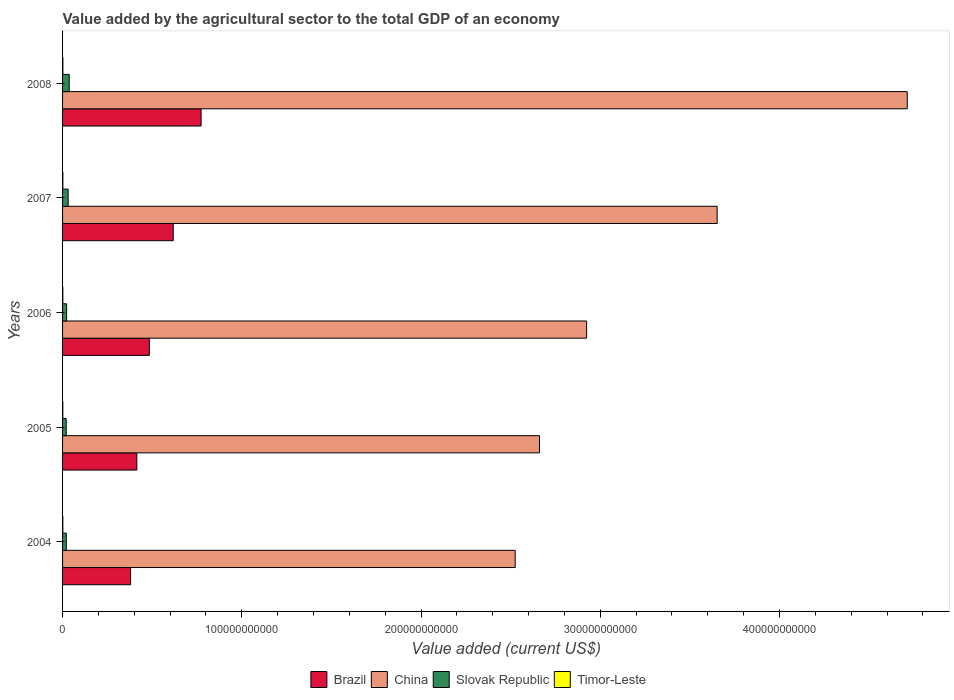Are the number of bars on each tick of the Y-axis equal?
Offer a terse response. Yes. What is the label of the 5th group of bars from the top?
Keep it short and to the point. 2004. In how many cases, is the number of bars for a given year not equal to the number of legend labels?
Ensure brevity in your answer.  0. What is the value added by the agricultural sector to the total GDP in China in 2006?
Your answer should be very brief. 2.92e+11. Across all years, what is the maximum value added by the agricultural sector to the total GDP in Brazil?
Keep it short and to the point. 7.73e+1. Across all years, what is the minimum value added by the agricultural sector to the total GDP in Brazil?
Your answer should be very brief. 3.80e+1. In which year was the value added by the agricultural sector to the total GDP in China minimum?
Provide a succinct answer. 2004. What is the total value added by the agricultural sector to the total GDP in China in the graph?
Give a very brief answer. 1.65e+12. What is the difference between the value added by the agricultural sector to the total GDP in China in 2004 and that in 2006?
Provide a short and direct response. -3.98e+1. What is the difference between the value added by the agricultural sector to the total GDP in Brazil in 2008 and the value added by the agricultural sector to the total GDP in China in 2007?
Provide a short and direct response. -2.88e+11. What is the average value added by the agricultural sector to the total GDP in Slovak Republic per year?
Provide a succinct answer. 2.64e+09. In the year 2006, what is the difference between the value added by the agricultural sector to the total GDP in Timor-Leste and value added by the agricultural sector to the total GDP in Slovak Republic?
Your answer should be compact. -2.12e+09. In how many years, is the value added by the agricultural sector to the total GDP in Slovak Republic greater than 200000000000 US$?
Offer a terse response. 0. What is the ratio of the value added by the agricultural sector to the total GDP in Slovak Republic in 2007 to that in 2008?
Make the answer very short. 0.84. Is the difference between the value added by the agricultural sector to the total GDP in Timor-Leste in 2004 and 2006 greater than the difference between the value added by the agricultural sector to the total GDP in Slovak Republic in 2004 and 2006?
Provide a short and direct response. Yes. What is the difference between the highest and the second highest value added by the agricultural sector to the total GDP in China?
Keep it short and to the point. 1.06e+11. What is the difference between the highest and the lowest value added by the agricultural sector to the total GDP in Timor-Leste?
Make the answer very short. 3.60e+07. In how many years, is the value added by the agricultural sector to the total GDP in Slovak Republic greater than the average value added by the agricultural sector to the total GDP in Slovak Republic taken over all years?
Your response must be concise. 2. What does the 4th bar from the top in 2007 represents?
Keep it short and to the point. Brazil. What does the 3rd bar from the bottom in 2007 represents?
Offer a terse response. Slovak Republic. Is it the case that in every year, the sum of the value added by the agricultural sector to the total GDP in Slovak Republic and value added by the agricultural sector to the total GDP in China is greater than the value added by the agricultural sector to the total GDP in Timor-Leste?
Offer a terse response. Yes. What is the difference between two consecutive major ticks on the X-axis?
Offer a very short reply. 1.00e+11. Does the graph contain any zero values?
Ensure brevity in your answer.  No. How are the legend labels stacked?
Give a very brief answer. Horizontal. What is the title of the graph?
Offer a terse response. Value added by the agricultural sector to the total GDP of an economy. What is the label or title of the X-axis?
Offer a very short reply. Value added (current US$). What is the label or title of the Y-axis?
Your answer should be very brief. Years. What is the Value added (current US$) in Brazil in 2004?
Your answer should be very brief. 3.80e+1. What is the Value added (current US$) of China in 2004?
Your response must be concise. 2.53e+11. What is the Value added (current US$) of Slovak Republic in 2004?
Your response must be concise. 2.09e+09. What is the Value added (current US$) in Timor-Leste in 2004?
Your response must be concise. 1.35e+08. What is the Value added (current US$) of Brazil in 2005?
Offer a terse response. 4.14e+1. What is the Value added (current US$) of China in 2005?
Ensure brevity in your answer.  2.66e+11. What is the Value added (current US$) of Slovak Republic in 2005?
Your response must be concise. 2.02e+09. What is the Value added (current US$) in Timor-Leste in 2005?
Make the answer very short. 1.35e+08. What is the Value added (current US$) in Brazil in 2006?
Your answer should be very brief. 4.84e+1. What is the Value added (current US$) of China in 2006?
Your response must be concise. 2.92e+11. What is the Value added (current US$) in Slovak Republic in 2006?
Give a very brief answer. 2.27e+09. What is the Value added (current US$) of Timor-Leste in 2006?
Your answer should be compact. 1.45e+08. What is the Value added (current US$) in Brazil in 2007?
Your answer should be compact. 6.17e+1. What is the Value added (current US$) of China in 2007?
Make the answer very short. 3.65e+11. What is the Value added (current US$) of Slovak Republic in 2007?
Your answer should be compact. 3.11e+09. What is the Value added (current US$) of Timor-Leste in 2007?
Provide a succinct answer. 1.59e+08. What is the Value added (current US$) of Brazil in 2008?
Your answer should be very brief. 7.73e+1. What is the Value added (current US$) of China in 2008?
Keep it short and to the point. 4.71e+11. What is the Value added (current US$) in Slovak Republic in 2008?
Offer a very short reply. 3.71e+09. What is the Value added (current US$) in Timor-Leste in 2008?
Provide a short and direct response. 1.71e+08. Across all years, what is the maximum Value added (current US$) in Brazil?
Provide a short and direct response. 7.73e+1. Across all years, what is the maximum Value added (current US$) of China?
Your answer should be very brief. 4.71e+11. Across all years, what is the maximum Value added (current US$) of Slovak Republic?
Make the answer very short. 3.71e+09. Across all years, what is the maximum Value added (current US$) in Timor-Leste?
Keep it short and to the point. 1.71e+08. Across all years, what is the minimum Value added (current US$) of Brazil?
Make the answer very short. 3.80e+1. Across all years, what is the minimum Value added (current US$) of China?
Offer a terse response. 2.53e+11. Across all years, what is the minimum Value added (current US$) of Slovak Republic?
Your response must be concise. 2.02e+09. Across all years, what is the minimum Value added (current US$) of Timor-Leste?
Offer a terse response. 1.35e+08. What is the total Value added (current US$) of Brazil in the graph?
Give a very brief answer. 2.67e+11. What is the total Value added (current US$) of China in the graph?
Offer a very short reply. 1.65e+12. What is the total Value added (current US$) in Slovak Republic in the graph?
Give a very brief answer. 1.32e+1. What is the total Value added (current US$) in Timor-Leste in the graph?
Your answer should be very brief. 7.45e+08. What is the difference between the Value added (current US$) of Brazil in 2004 and that in 2005?
Your response must be concise. -3.47e+09. What is the difference between the Value added (current US$) in China in 2004 and that in 2005?
Offer a very short reply. -1.35e+1. What is the difference between the Value added (current US$) of Slovak Republic in 2004 and that in 2005?
Provide a short and direct response. 6.67e+07. What is the difference between the Value added (current US$) of Brazil in 2004 and that in 2006?
Keep it short and to the point. -1.04e+1. What is the difference between the Value added (current US$) in China in 2004 and that in 2006?
Your answer should be very brief. -3.98e+1. What is the difference between the Value added (current US$) in Slovak Republic in 2004 and that in 2006?
Give a very brief answer. -1.82e+08. What is the difference between the Value added (current US$) of Timor-Leste in 2004 and that in 2006?
Your answer should be very brief. -1.00e+07. What is the difference between the Value added (current US$) of Brazil in 2004 and that in 2007?
Give a very brief answer. -2.38e+1. What is the difference between the Value added (current US$) of China in 2004 and that in 2007?
Offer a very short reply. -1.13e+11. What is the difference between the Value added (current US$) in Slovak Republic in 2004 and that in 2007?
Your response must be concise. -1.02e+09. What is the difference between the Value added (current US$) of Timor-Leste in 2004 and that in 2007?
Your answer should be very brief. -2.40e+07. What is the difference between the Value added (current US$) in Brazil in 2004 and that in 2008?
Ensure brevity in your answer.  -3.93e+1. What is the difference between the Value added (current US$) of China in 2004 and that in 2008?
Keep it short and to the point. -2.19e+11. What is the difference between the Value added (current US$) of Slovak Republic in 2004 and that in 2008?
Your response must be concise. -1.63e+09. What is the difference between the Value added (current US$) of Timor-Leste in 2004 and that in 2008?
Give a very brief answer. -3.60e+07. What is the difference between the Value added (current US$) of Brazil in 2005 and that in 2006?
Make the answer very short. -6.97e+09. What is the difference between the Value added (current US$) of China in 2005 and that in 2006?
Give a very brief answer. -2.63e+1. What is the difference between the Value added (current US$) of Slovak Republic in 2005 and that in 2006?
Offer a terse response. -2.49e+08. What is the difference between the Value added (current US$) of Timor-Leste in 2005 and that in 2006?
Your answer should be very brief. -1.00e+07. What is the difference between the Value added (current US$) of Brazil in 2005 and that in 2007?
Provide a short and direct response. -2.03e+1. What is the difference between the Value added (current US$) in China in 2005 and that in 2007?
Provide a short and direct response. -9.91e+1. What is the difference between the Value added (current US$) in Slovak Republic in 2005 and that in 2007?
Make the answer very short. -1.09e+09. What is the difference between the Value added (current US$) of Timor-Leste in 2005 and that in 2007?
Your answer should be compact. -2.40e+07. What is the difference between the Value added (current US$) of Brazil in 2005 and that in 2008?
Give a very brief answer. -3.58e+1. What is the difference between the Value added (current US$) of China in 2005 and that in 2008?
Offer a very short reply. -2.05e+11. What is the difference between the Value added (current US$) of Slovak Republic in 2005 and that in 2008?
Offer a very short reply. -1.69e+09. What is the difference between the Value added (current US$) of Timor-Leste in 2005 and that in 2008?
Your answer should be very brief. -3.60e+07. What is the difference between the Value added (current US$) in Brazil in 2006 and that in 2007?
Make the answer very short. -1.33e+1. What is the difference between the Value added (current US$) of China in 2006 and that in 2007?
Your answer should be compact. -7.28e+1. What is the difference between the Value added (current US$) of Slovak Republic in 2006 and that in 2007?
Offer a very short reply. -8.42e+08. What is the difference between the Value added (current US$) in Timor-Leste in 2006 and that in 2007?
Give a very brief answer. -1.40e+07. What is the difference between the Value added (current US$) of Brazil in 2006 and that in 2008?
Ensure brevity in your answer.  -2.89e+1. What is the difference between the Value added (current US$) in China in 2006 and that in 2008?
Ensure brevity in your answer.  -1.79e+11. What is the difference between the Value added (current US$) in Slovak Republic in 2006 and that in 2008?
Your response must be concise. -1.45e+09. What is the difference between the Value added (current US$) in Timor-Leste in 2006 and that in 2008?
Your response must be concise. -2.60e+07. What is the difference between the Value added (current US$) in Brazil in 2007 and that in 2008?
Your answer should be compact. -1.55e+1. What is the difference between the Value added (current US$) in China in 2007 and that in 2008?
Your answer should be very brief. -1.06e+11. What is the difference between the Value added (current US$) of Slovak Republic in 2007 and that in 2008?
Keep it short and to the point. -6.04e+08. What is the difference between the Value added (current US$) in Timor-Leste in 2007 and that in 2008?
Your answer should be very brief. -1.20e+07. What is the difference between the Value added (current US$) in Brazil in 2004 and the Value added (current US$) in China in 2005?
Offer a very short reply. -2.28e+11. What is the difference between the Value added (current US$) in Brazil in 2004 and the Value added (current US$) in Slovak Republic in 2005?
Provide a short and direct response. 3.59e+1. What is the difference between the Value added (current US$) of Brazil in 2004 and the Value added (current US$) of Timor-Leste in 2005?
Make the answer very short. 3.78e+1. What is the difference between the Value added (current US$) in China in 2004 and the Value added (current US$) in Slovak Republic in 2005?
Provide a succinct answer. 2.51e+11. What is the difference between the Value added (current US$) of China in 2004 and the Value added (current US$) of Timor-Leste in 2005?
Offer a very short reply. 2.52e+11. What is the difference between the Value added (current US$) of Slovak Republic in 2004 and the Value added (current US$) of Timor-Leste in 2005?
Provide a short and direct response. 1.95e+09. What is the difference between the Value added (current US$) in Brazil in 2004 and the Value added (current US$) in China in 2006?
Provide a succinct answer. -2.54e+11. What is the difference between the Value added (current US$) in Brazil in 2004 and the Value added (current US$) in Slovak Republic in 2006?
Offer a very short reply. 3.57e+1. What is the difference between the Value added (current US$) of Brazil in 2004 and the Value added (current US$) of Timor-Leste in 2006?
Provide a succinct answer. 3.78e+1. What is the difference between the Value added (current US$) in China in 2004 and the Value added (current US$) in Slovak Republic in 2006?
Your answer should be very brief. 2.50e+11. What is the difference between the Value added (current US$) of China in 2004 and the Value added (current US$) of Timor-Leste in 2006?
Keep it short and to the point. 2.52e+11. What is the difference between the Value added (current US$) of Slovak Republic in 2004 and the Value added (current US$) of Timor-Leste in 2006?
Offer a terse response. 1.94e+09. What is the difference between the Value added (current US$) in Brazil in 2004 and the Value added (current US$) in China in 2007?
Offer a very short reply. -3.27e+11. What is the difference between the Value added (current US$) of Brazil in 2004 and the Value added (current US$) of Slovak Republic in 2007?
Make the answer very short. 3.49e+1. What is the difference between the Value added (current US$) in Brazil in 2004 and the Value added (current US$) in Timor-Leste in 2007?
Offer a very short reply. 3.78e+1. What is the difference between the Value added (current US$) of China in 2004 and the Value added (current US$) of Slovak Republic in 2007?
Ensure brevity in your answer.  2.49e+11. What is the difference between the Value added (current US$) in China in 2004 and the Value added (current US$) in Timor-Leste in 2007?
Offer a terse response. 2.52e+11. What is the difference between the Value added (current US$) of Slovak Republic in 2004 and the Value added (current US$) of Timor-Leste in 2007?
Keep it short and to the point. 1.93e+09. What is the difference between the Value added (current US$) of Brazil in 2004 and the Value added (current US$) of China in 2008?
Offer a terse response. -4.33e+11. What is the difference between the Value added (current US$) in Brazil in 2004 and the Value added (current US$) in Slovak Republic in 2008?
Your answer should be very brief. 3.42e+1. What is the difference between the Value added (current US$) in Brazil in 2004 and the Value added (current US$) in Timor-Leste in 2008?
Keep it short and to the point. 3.78e+1. What is the difference between the Value added (current US$) of China in 2004 and the Value added (current US$) of Slovak Republic in 2008?
Ensure brevity in your answer.  2.49e+11. What is the difference between the Value added (current US$) of China in 2004 and the Value added (current US$) of Timor-Leste in 2008?
Make the answer very short. 2.52e+11. What is the difference between the Value added (current US$) in Slovak Republic in 2004 and the Value added (current US$) in Timor-Leste in 2008?
Offer a very short reply. 1.91e+09. What is the difference between the Value added (current US$) of Brazil in 2005 and the Value added (current US$) of China in 2006?
Provide a succinct answer. -2.51e+11. What is the difference between the Value added (current US$) in Brazil in 2005 and the Value added (current US$) in Slovak Republic in 2006?
Your answer should be very brief. 3.92e+1. What is the difference between the Value added (current US$) in Brazil in 2005 and the Value added (current US$) in Timor-Leste in 2006?
Your answer should be very brief. 4.13e+1. What is the difference between the Value added (current US$) in China in 2005 and the Value added (current US$) in Slovak Republic in 2006?
Provide a short and direct response. 2.64e+11. What is the difference between the Value added (current US$) of China in 2005 and the Value added (current US$) of Timor-Leste in 2006?
Offer a terse response. 2.66e+11. What is the difference between the Value added (current US$) of Slovak Republic in 2005 and the Value added (current US$) of Timor-Leste in 2006?
Give a very brief answer. 1.87e+09. What is the difference between the Value added (current US$) in Brazil in 2005 and the Value added (current US$) in China in 2007?
Offer a very short reply. -3.24e+11. What is the difference between the Value added (current US$) of Brazil in 2005 and the Value added (current US$) of Slovak Republic in 2007?
Offer a terse response. 3.83e+1. What is the difference between the Value added (current US$) in Brazil in 2005 and the Value added (current US$) in Timor-Leste in 2007?
Your answer should be very brief. 4.13e+1. What is the difference between the Value added (current US$) of China in 2005 and the Value added (current US$) of Slovak Republic in 2007?
Keep it short and to the point. 2.63e+11. What is the difference between the Value added (current US$) of China in 2005 and the Value added (current US$) of Timor-Leste in 2007?
Give a very brief answer. 2.66e+11. What is the difference between the Value added (current US$) in Slovak Republic in 2005 and the Value added (current US$) in Timor-Leste in 2007?
Ensure brevity in your answer.  1.86e+09. What is the difference between the Value added (current US$) in Brazil in 2005 and the Value added (current US$) in China in 2008?
Provide a short and direct response. -4.30e+11. What is the difference between the Value added (current US$) in Brazil in 2005 and the Value added (current US$) in Slovak Republic in 2008?
Ensure brevity in your answer.  3.77e+1. What is the difference between the Value added (current US$) in Brazil in 2005 and the Value added (current US$) in Timor-Leste in 2008?
Keep it short and to the point. 4.13e+1. What is the difference between the Value added (current US$) of China in 2005 and the Value added (current US$) of Slovak Republic in 2008?
Provide a short and direct response. 2.62e+11. What is the difference between the Value added (current US$) of China in 2005 and the Value added (current US$) of Timor-Leste in 2008?
Give a very brief answer. 2.66e+11. What is the difference between the Value added (current US$) in Slovak Republic in 2005 and the Value added (current US$) in Timor-Leste in 2008?
Provide a short and direct response. 1.85e+09. What is the difference between the Value added (current US$) in Brazil in 2006 and the Value added (current US$) in China in 2007?
Provide a short and direct response. -3.17e+11. What is the difference between the Value added (current US$) of Brazil in 2006 and the Value added (current US$) of Slovak Republic in 2007?
Your answer should be compact. 4.53e+1. What is the difference between the Value added (current US$) of Brazil in 2006 and the Value added (current US$) of Timor-Leste in 2007?
Offer a terse response. 4.82e+1. What is the difference between the Value added (current US$) in China in 2006 and the Value added (current US$) in Slovak Republic in 2007?
Provide a succinct answer. 2.89e+11. What is the difference between the Value added (current US$) in China in 2006 and the Value added (current US$) in Timor-Leste in 2007?
Ensure brevity in your answer.  2.92e+11. What is the difference between the Value added (current US$) of Slovak Republic in 2006 and the Value added (current US$) of Timor-Leste in 2007?
Your answer should be very brief. 2.11e+09. What is the difference between the Value added (current US$) in Brazil in 2006 and the Value added (current US$) in China in 2008?
Your response must be concise. -4.23e+11. What is the difference between the Value added (current US$) of Brazil in 2006 and the Value added (current US$) of Slovak Republic in 2008?
Keep it short and to the point. 4.47e+1. What is the difference between the Value added (current US$) of Brazil in 2006 and the Value added (current US$) of Timor-Leste in 2008?
Make the answer very short. 4.82e+1. What is the difference between the Value added (current US$) in China in 2006 and the Value added (current US$) in Slovak Republic in 2008?
Make the answer very short. 2.89e+11. What is the difference between the Value added (current US$) of China in 2006 and the Value added (current US$) of Timor-Leste in 2008?
Give a very brief answer. 2.92e+11. What is the difference between the Value added (current US$) of Slovak Republic in 2006 and the Value added (current US$) of Timor-Leste in 2008?
Offer a very short reply. 2.10e+09. What is the difference between the Value added (current US$) in Brazil in 2007 and the Value added (current US$) in China in 2008?
Make the answer very short. -4.10e+11. What is the difference between the Value added (current US$) in Brazil in 2007 and the Value added (current US$) in Slovak Republic in 2008?
Your answer should be very brief. 5.80e+1. What is the difference between the Value added (current US$) of Brazil in 2007 and the Value added (current US$) of Timor-Leste in 2008?
Your answer should be very brief. 6.16e+1. What is the difference between the Value added (current US$) in China in 2007 and the Value added (current US$) in Slovak Republic in 2008?
Keep it short and to the point. 3.61e+11. What is the difference between the Value added (current US$) of China in 2007 and the Value added (current US$) of Timor-Leste in 2008?
Your answer should be very brief. 3.65e+11. What is the difference between the Value added (current US$) of Slovak Republic in 2007 and the Value added (current US$) of Timor-Leste in 2008?
Offer a terse response. 2.94e+09. What is the average Value added (current US$) in Brazil per year?
Provide a succinct answer. 5.34e+1. What is the average Value added (current US$) in China per year?
Give a very brief answer. 3.29e+11. What is the average Value added (current US$) in Slovak Republic per year?
Your response must be concise. 2.64e+09. What is the average Value added (current US$) of Timor-Leste per year?
Your answer should be very brief. 1.49e+08. In the year 2004, what is the difference between the Value added (current US$) in Brazil and Value added (current US$) in China?
Give a very brief answer. -2.15e+11. In the year 2004, what is the difference between the Value added (current US$) in Brazil and Value added (current US$) in Slovak Republic?
Your answer should be very brief. 3.59e+1. In the year 2004, what is the difference between the Value added (current US$) in Brazil and Value added (current US$) in Timor-Leste?
Ensure brevity in your answer.  3.78e+1. In the year 2004, what is the difference between the Value added (current US$) in China and Value added (current US$) in Slovak Republic?
Ensure brevity in your answer.  2.50e+11. In the year 2004, what is the difference between the Value added (current US$) of China and Value added (current US$) of Timor-Leste?
Provide a short and direct response. 2.52e+11. In the year 2004, what is the difference between the Value added (current US$) of Slovak Republic and Value added (current US$) of Timor-Leste?
Your answer should be compact. 1.95e+09. In the year 2005, what is the difference between the Value added (current US$) of Brazil and Value added (current US$) of China?
Your answer should be compact. -2.25e+11. In the year 2005, what is the difference between the Value added (current US$) in Brazil and Value added (current US$) in Slovak Republic?
Offer a terse response. 3.94e+1. In the year 2005, what is the difference between the Value added (current US$) of Brazil and Value added (current US$) of Timor-Leste?
Offer a terse response. 4.13e+1. In the year 2005, what is the difference between the Value added (current US$) of China and Value added (current US$) of Slovak Republic?
Provide a short and direct response. 2.64e+11. In the year 2005, what is the difference between the Value added (current US$) of China and Value added (current US$) of Timor-Leste?
Offer a terse response. 2.66e+11. In the year 2005, what is the difference between the Value added (current US$) of Slovak Republic and Value added (current US$) of Timor-Leste?
Your response must be concise. 1.88e+09. In the year 2006, what is the difference between the Value added (current US$) in Brazil and Value added (current US$) in China?
Offer a very short reply. -2.44e+11. In the year 2006, what is the difference between the Value added (current US$) of Brazil and Value added (current US$) of Slovak Republic?
Offer a terse response. 4.61e+1. In the year 2006, what is the difference between the Value added (current US$) of Brazil and Value added (current US$) of Timor-Leste?
Ensure brevity in your answer.  4.83e+1. In the year 2006, what is the difference between the Value added (current US$) of China and Value added (current US$) of Slovak Republic?
Your response must be concise. 2.90e+11. In the year 2006, what is the difference between the Value added (current US$) of China and Value added (current US$) of Timor-Leste?
Your response must be concise. 2.92e+11. In the year 2006, what is the difference between the Value added (current US$) of Slovak Republic and Value added (current US$) of Timor-Leste?
Provide a succinct answer. 2.12e+09. In the year 2007, what is the difference between the Value added (current US$) of Brazil and Value added (current US$) of China?
Offer a terse response. -3.03e+11. In the year 2007, what is the difference between the Value added (current US$) of Brazil and Value added (current US$) of Slovak Republic?
Offer a very short reply. 5.86e+1. In the year 2007, what is the difference between the Value added (current US$) of Brazil and Value added (current US$) of Timor-Leste?
Offer a very short reply. 6.16e+1. In the year 2007, what is the difference between the Value added (current US$) of China and Value added (current US$) of Slovak Republic?
Give a very brief answer. 3.62e+11. In the year 2007, what is the difference between the Value added (current US$) of China and Value added (current US$) of Timor-Leste?
Your answer should be very brief. 3.65e+11. In the year 2007, what is the difference between the Value added (current US$) of Slovak Republic and Value added (current US$) of Timor-Leste?
Your answer should be very brief. 2.95e+09. In the year 2008, what is the difference between the Value added (current US$) of Brazil and Value added (current US$) of China?
Your answer should be compact. -3.94e+11. In the year 2008, what is the difference between the Value added (current US$) of Brazil and Value added (current US$) of Slovak Republic?
Make the answer very short. 7.36e+1. In the year 2008, what is the difference between the Value added (current US$) in Brazil and Value added (current US$) in Timor-Leste?
Provide a short and direct response. 7.71e+1. In the year 2008, what is the difference between the Value added (current US$) of China and Value added (current US$) of Slovak Republic?
Your answer should be very brief. 4.68e+11. In the year 2008, what is the difference between the Value added (current US$) of China and Value added (current US$) of Timor-Leste?
Give a very brief answer. 4.71e+11. In the year 2008, what is the difference between the Value added (current US$) in Slovak Republic and Value added (current US$) in Timor-Leste?
Provide a succinct answer. 3.54e+09. What is the ratio of the Value added (current US$) of Brazil in 2004 to that in 2005?
Ensure brevity in your answer.  0.92. What is the ratio of the Value added (current US$) in China in 2004 to that in 2005?
Your response must be concise. 0.95. What is the ratio of the Value added (current US$) of Slovak Republic in 2004 to that in 2005?
Your answer should be compact. 1.03. What is the ratio of the Value added (current US$) in Timor-Leste in 2004 to that in 2005?
Provide a succinct answer. 1. What is the ratio of the Value added (current US$) in Brazil in 2004 to that in 2006?
Offer a very short reply. 0.78. What is the ratio of the Value added (current US$) of China in 2004 to that in 2006?
Ensure brevity in your answer.  0.86. What is the ratio of the Value added (current US$) in Slovak Republic in 2004 to that in 2006?
Offer a very short reply. 0.92. What is the ratio of the Value added (current US$) of Brazil in 2004 to that in 2007?
Offer a terse response. 0.61. What is the ratio of the Value added (current US$) in China in 2004 to that in 2007?
Provide a short and direct response. 0.69. What is the ratio of the Value added (current US$) in Slovak Republic in 2004 to that in 2007?
Provide a short and direct response. 0.67. What is the ratio of the Value added (current US$) of Timor-Leste in 2004 to that in 2007?
Keep it short and to the point. 0.85. What is the ratio of the Value added (current US$) in Brazil in 2004 to that in 2008?
Keep it short and to the point. 0.49. What is the ratio of the Value added (current US$) of China in 2004 to that in 2008?
Provide a succinct answer. 0.54. What is the ratio of the Value added (current US$) in Slovak Republic in 2004 to that in 2008?
Make the answer very short. 0.56. What is the ratio of the Value added (current US$) in Timor-Leste in 2004 to that in 2008?
Your answer should be compact. 0.79. What is the ratio of the Value added (current US$) in Brazil in 2005 to that in 2006?
Offer a terse response. 0.86. What is the ratio of the Value added (current US$) of China in 2005 to that in 2006?
Provide a short and direct response. 0.91. What is the ratio of the Value added (current US$) in Slovak Republic in 2005 to that in 2006?
Provide a succinct answer. 0.89. What is the ratio of the Value added (current US$) in Brazil in 2005 to that in 2007?
Provide a short and direct response. 0.67. What is the ratio of the Value added (current US$) of China in 2005 to that in 2007?
Give a very brief answer. 0.73. What is the ratio of the Value added (current US$) of Slovak Republic in 2005 to that in 2007?
Provide a succinct answer. 0.65. What is the ratio of the Value added (current US$) of Timor-Leste in 2005 to that in 2007?
Make the answer very short. 0.85. What is the ratio of the Value added (current US$) of Brazil in 2005 to that in 2008?
Ensure brevity in your answer.  0.54. What is the ratio of the Value added (current US$) of China in 2005 to that in 2008?
Your answer should be compact. 0.56. What is the ratio of the Value added (current US$) of Slovak Republic in 2005 to that in 2008?
Offer a very short reply. 0.54. What is the ratio of the Value added (current US$) in Timor-Leste in 2005 to that in 2008?
Ensure brevity in your answer.  0.79. What is the ratio of the Value added (current US$) in Brazil in 2006 to that in 2007?
Ensure brevity in your answer.  0.78. What is the ratio of the Value added (current US$) in China in 2006 to that in 2007?
Ensure brevity in your answer.  0.8. What is the ratio of the Value added (current US$) of Slovak Republic in 2006 to that in 2007?
Provide a short and direct response. 0.73. What is the ratio of the Value added (current US$) of Timor-Leste in 2006 to that in 2007?
Keep it short and to the point. 0.91. What is the ratio of the Value added (current US$) in Brazil in 2006 to that in 2008?
Your answer should be compact. 0.63. What is the ratio of the Value added (current US$) in China in 2006 to that in 2008?
Give a very brief answer. 0.62. What is the ratio of the Value added (current US$) of Slovak Republic in 2006 to that in 2008?
Provide a succinct answer. 0.61. What is the ratio of the Value added (current US$) in Timor-Leste in 2006 to that in 2008?
Your answer should be compact. 0.85. What is the ratio of the Value added (current US$) in Brazil in 2007 to that in 2008?
Provide a short and direct response. 0.8. What is the ratio of the Value added (current US$) of China in 2007 to that in 2008?
Keep it short and to the point. 0.77. What is the ratio of the Value added (current US$) of Slovak Republic in 2007 to that in 2008?
Make the answer very short. 0.84. What is the ratio of the Value added (current US$) of Timor-Leste in 2007 to that in 2008?
Provide a short and direct response. 0.93. What is the difference between the highest and the second highest Value added (current US$) in Brazil?
Ensure brevity in your answer.  1.55e+1. What is the difference between the highest and the second highest Value added (current US$) of China?
Give a very brief answer. 1.06e+11. What is the difference between the highest and the second highest Value added (current US$) in Slovak Republic?
Provide a short and direct response. 6.04e+08. What is the difference between the highest and the second highest Value added (current US$) in Timor-Leste?
Keep it short and to the point. 1.20e+07. What is the difference between the highest and the lowest Value added (current US$) of Brazil?
Your answer should be compact. 3.93e+1. What is the difference between the highest and the lowest Value added (current US$) in China?
Your answer should be compact. 2.19e+11. What is the difference between the highest and the lowest Value added (current US$) of Slovak Republic?
Offer a terse response. 1.69e+09. What is the difference between the highest and the lowest Value added (current US$) in Timor-Leste?
Offer a very short reply. 3.60e+07. 